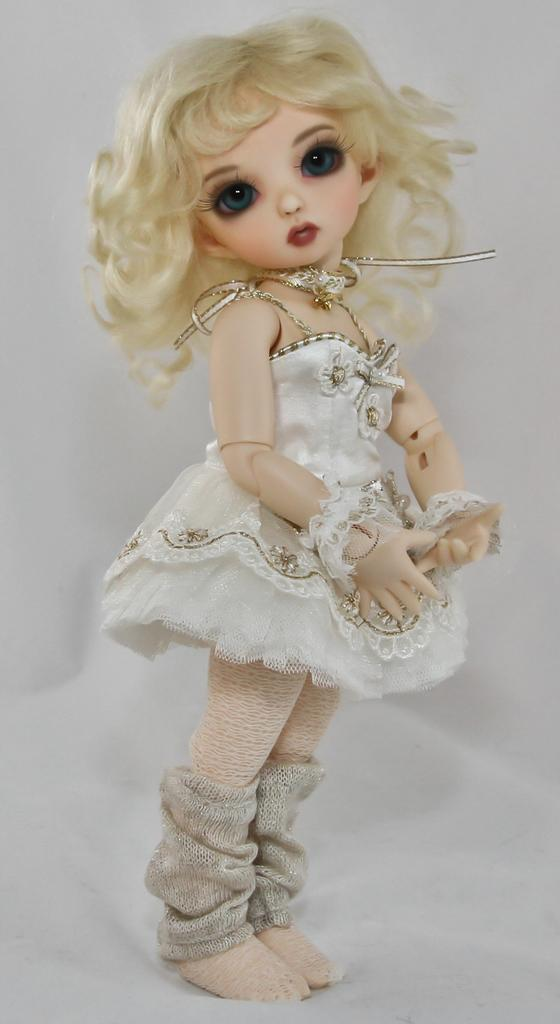What is the main subject in the image? There is a doll in the image. Can you describe the doll's location in the image? The doll is on an object. What type of tank can be seen in the image? There is no tank present in the image; it features a doll on an object. What kind of rock is the doll sitting on in the image? There is no rock present in the image; the doll is on an object, but its composition is not specified. 